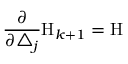Convert formula to latex. <formula><loc_0><loc_0><loc_500><loc_500>\frac { \partial } \partial \triangle _ { j } } H _ { k + 1 } = H</formula> 